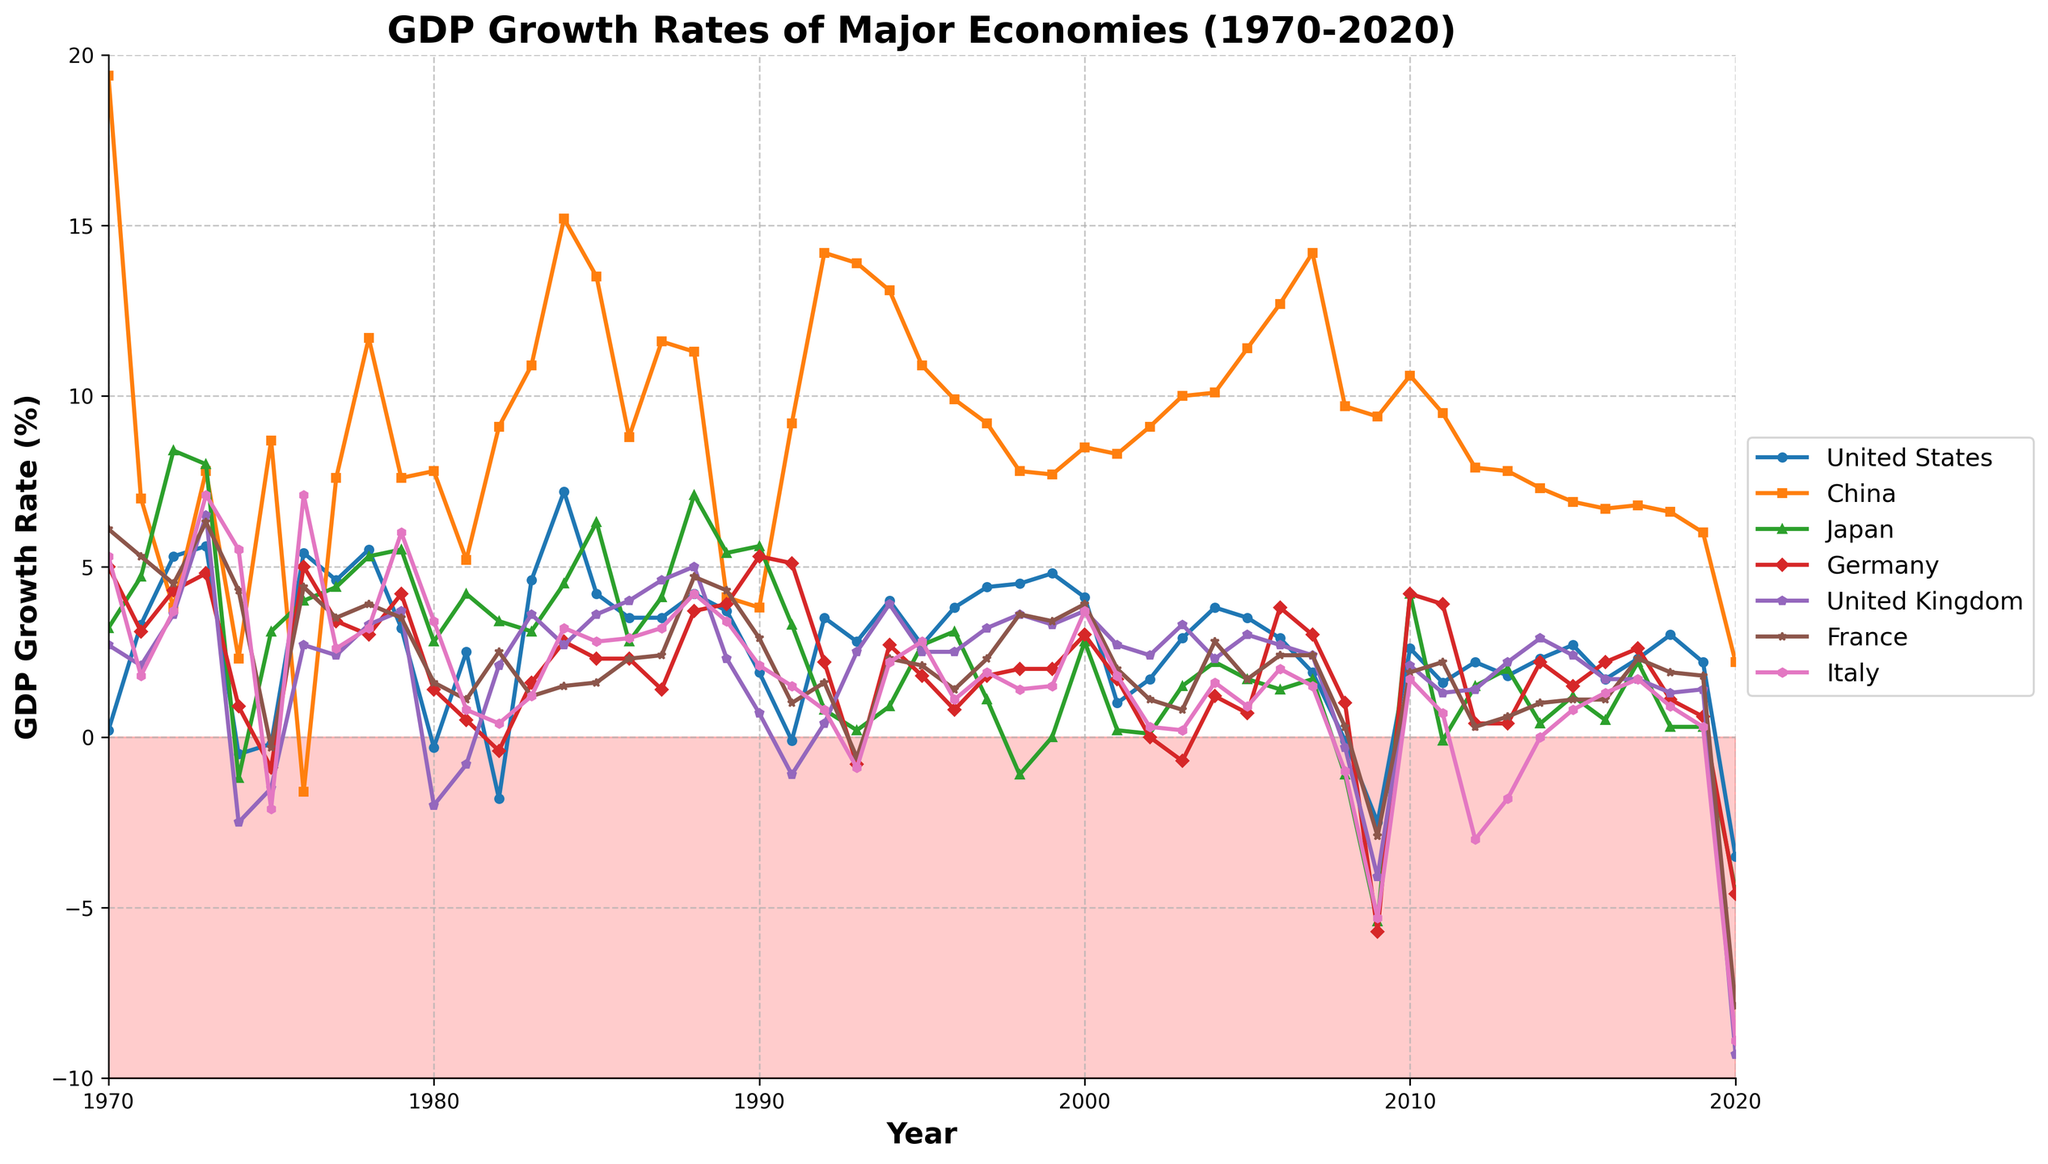What was the GDP growth rate of China in the year 2008, and how does it compare to Italy's growth rate the same year? The GDP growth rate of China in 2008 was 9.7%, and Italy's growth rate the same year was -1.0%. Thus, China's growth rate was significantly higher than Italy's.
Answer: China: 9.7%, Italy: -1.0%, China > Italy Which country had the highest GDP growth rate in 1984 and what was the rate? From the graph, it is clear that China had the highest GDP growth rate in 1984. The growth rate was 15.2%.
Answer: China, 15.2% Between 1970 and 2020, in which year did the United States experience the lowest GDP growth rate, and what was the rate? The United States experienced its lowest GDP growth rate in the year 2020 with a rate of -3.5%. This can be seen by observing the lowest point of the United States' line on the chart.
Answer: 2020, -3.5% What is the average GDP growth rate of Germany between 2000 and 2010? To find the average GDP growth rate of Germany between 2000 and 2010, we sum the growth rates from each year in this period and divide by the number of years. (3.0 + 1.7 + 0.0 + -0.7 + 1.2 + 0.7 + 3.8 + 3.0 + 1.0 + -5.7 + 4.2) / 11 = 1.09.
Answer: 1.09% Considering the data from 1970 to 2020, in which period did the United Kingdom experience the longest continuous recession (negative GDP growth rate)? The plot of the United Kingdom's GDP growth rate shows the longest period of negative growth occurred during 2008-2009. During these two years, the growth rates were -0.3% and -4.1% respectively.
Answer: 2008-2009 Which country showed the most stable GDP growth throughout the 1990s? By examining the lines, Japan showed relatively stable GDP growth in the 1990s with minimal fluctuation compared to other countries.
Answer: Japan How did France's GDP growth rate in 2020 compare to its growth rate in 1975? France's GDP growth rate in 2020 was -7.9%, while in 1975 it was -0.3%. This comparison shows a more severe recession in 2020.
Answer: Worse in 2020 What is the difference in GDP growth rates between the highest and lowest values recorded by China from 1970 to 2020? The highest GDP growth rate for China was 19.4% in 1970, and the lowest was -1.6% in 1976. Therefore, the difference is 19.4% - (-1.6%) = 21.0%.
Answer: 21.0% In which year did all countries except China experience a recession simultaneously, and what were the growth rates? In 1975, all countries except China experienced a recession simultaneously. The GDP growth rates were United States: -0.2%, Japan: 3.1%, Germany: -0.9%, United Kingdom: -1.5%, France: -0.3%, and Italy: -2.1%.
Answer: 1975 